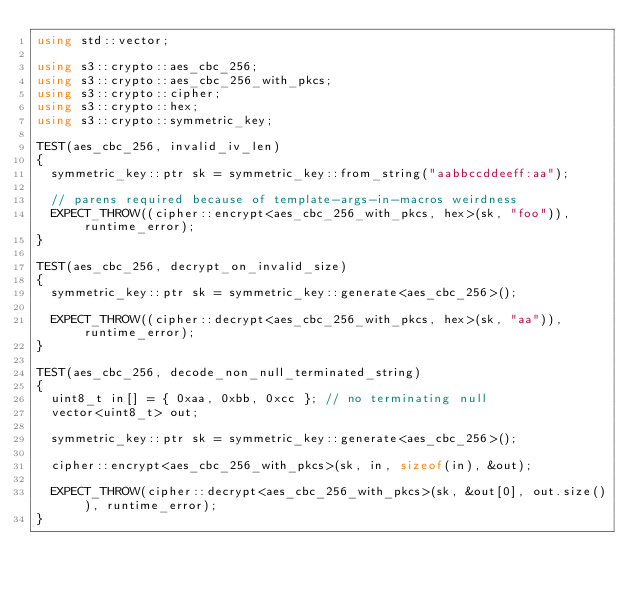Convert code to text. <code><loc_0><loc_0><loc_500><loc_500><_C++_>using std::vector;

using s3::crypto::aes_cbc_256;
using s3::crypto::aes_cbc_256_with_pkcs;
using s3::crypto::cipher;
using s3::crypto::hex;
using s3::crypto::symmetric_key;

TEST(aes_cbc_256, invalid_iv_len)
{
  symmetric_key::ptr sk = symmetric_key::from_string("aabbccddeeff:aa");

  // parens required because of template-args-in-macros weirdness
  EXPECT_THROW((cipher::encrypt<aes_cbc_256_with_pkcs, hex>(sk, "foo")), runtime_error);
}

TEST(aes_cbc_256, decrypt_on_invalid_size)
{
  symmetric_key::ptr sk = symmetric_key::generate<aes_cbc_256>();

  EXPECT_THROW((cipher::decrypt<aes_cbc_256_with_pkcs, hex>(sk, "aa")), runtime_error);
}

TEST(aes_cbc_256, decode_non_null_terminated_string)
{
  uint8_t in[] = { 0xaa, 0xbb, 0xcc }; // no terminating null
  vector<uint8_t> out;

  symmetric_key::ptr sk = symmetric_key::generate<aes_cbc_256>();

  cipher::encrypt<aes_cbc_256_with_pkcs>(sk, in, sizeof(in), &out);

  EXPECT_THROW(cipher::decrypt<aes_cbc_256_with_pkcs>(sk, &out[0], out.size()), runtime_error);
}
</code> 